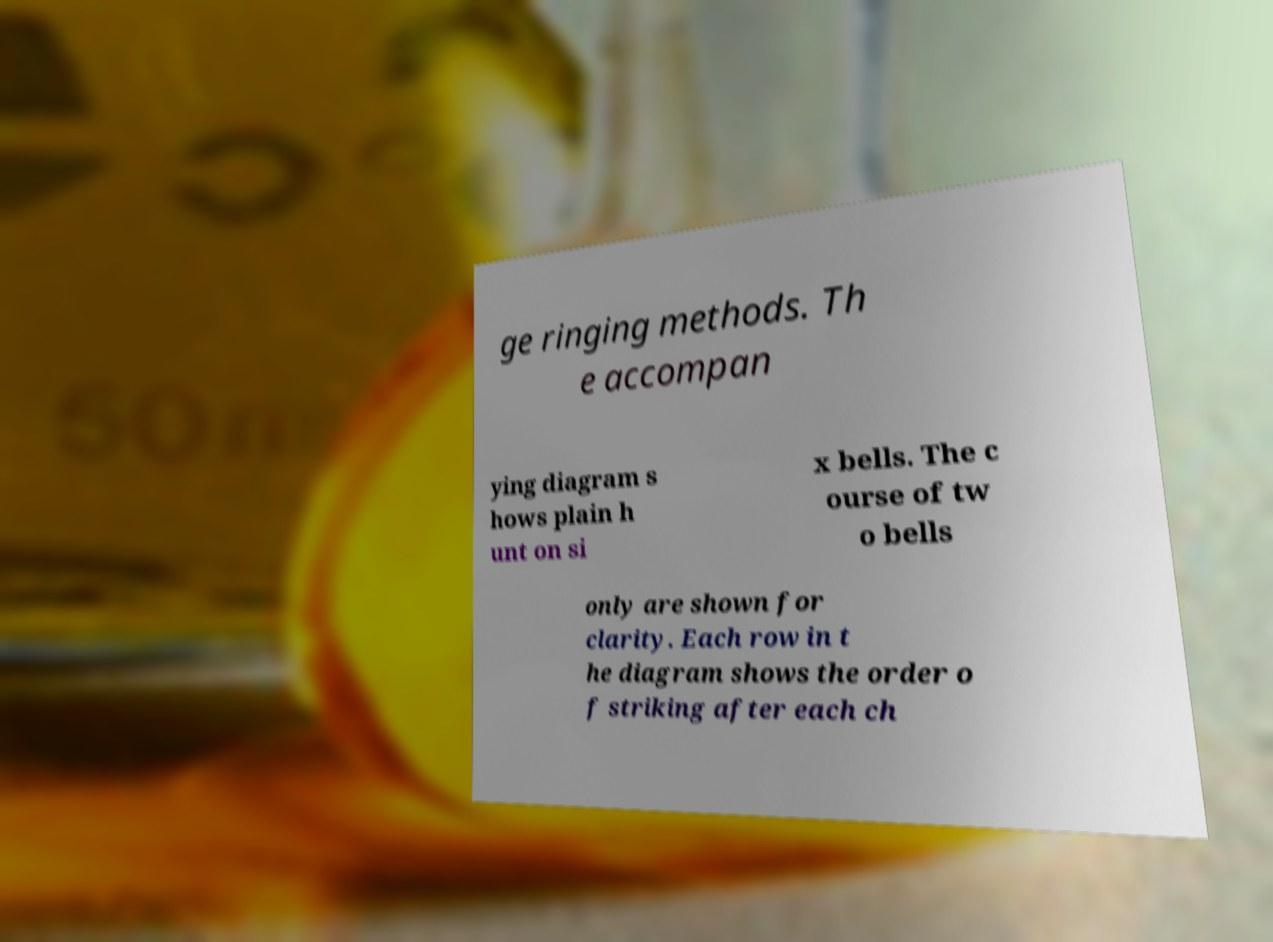Can you read and provide the text displayed in the image?This photo seems to have some interesting text. Can you extract and type it out for me? ge ringing methods. Th e accompan ying diagram s hows plain h unt on si x bells. The c ourse of tw o bells only are shown for clarity. Each row in t he diagram shows the order o f striking after each ch 